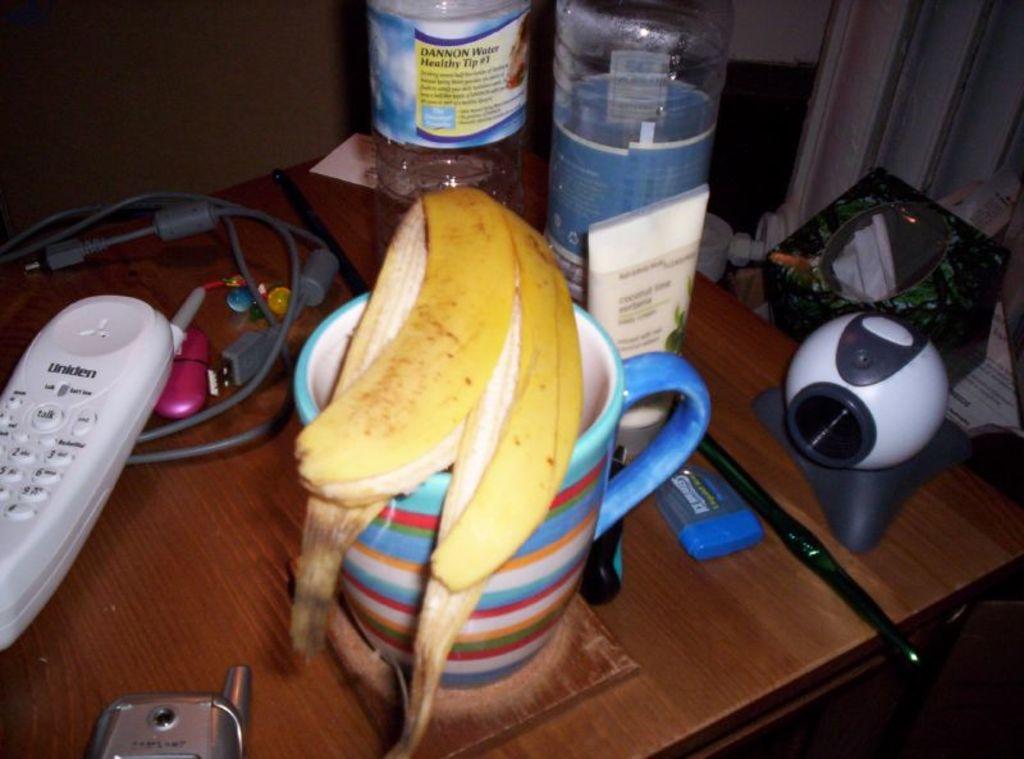What company makes the house phone?
Your answer should be very brief. Uniden. What brand is visible on the water bottle?
Keep it short and to the point. Dannon. 